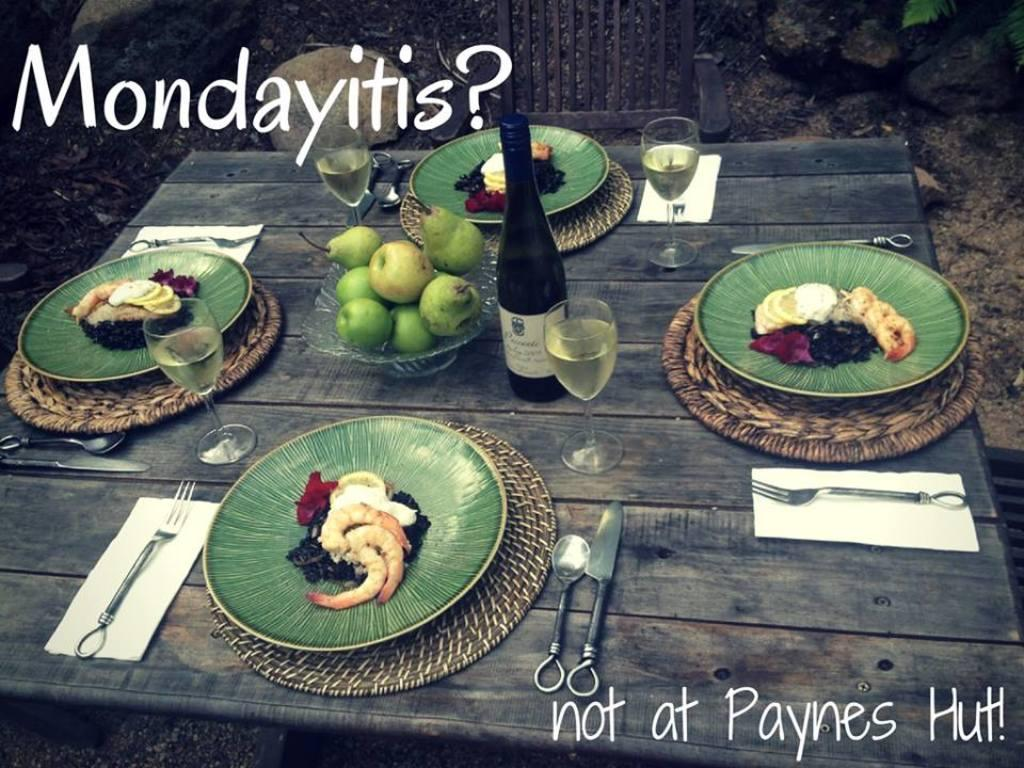What is present on the plates in the image? There are food items in the plates in the image. What else can be seen on the table in the image? There are bottles and glasses on the table in the image. Can you describe what is written on the image? Unfortunately, there is not enough information provided to determine what is written on the image. How does the soap in the image help to clean the dishes? There is no soap present in the image; it only mentions food items, bottles, and glasses on the table. 